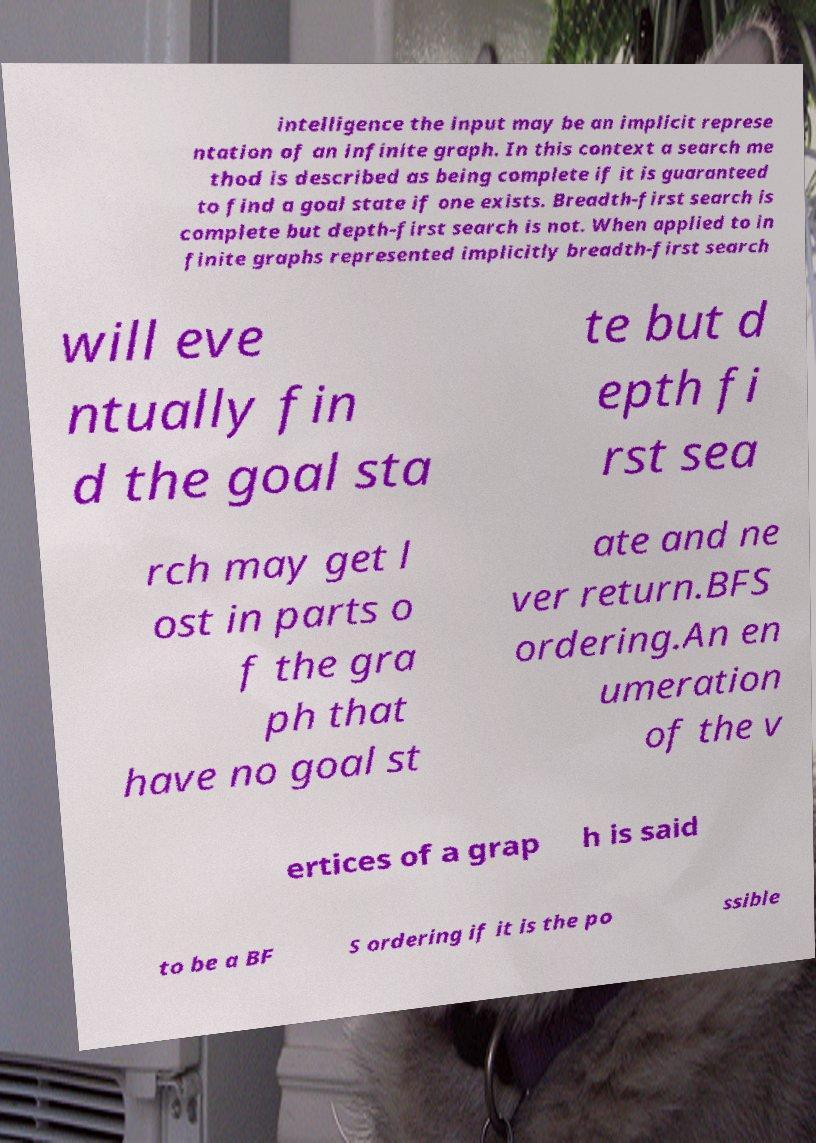What messages or text are displayed in this image? I need them in a readable, typed format. intelligence the input may be an implicit represe ntation of an infinite graph. In this context a search me thod is described as being complete if it is guaranteed to find a goal state if one exists. Breadth-first search is complete but depth-first search is not. When applied to in finite graphs represented implicitly breadth-first search will eve ntually fin d the goal sta te but d epth fi rst sea rch may get l ost in parts o f the gra ph that have no goal st ate and ne ver return.BFS ordering.An en umeration of the v ertices of a grap h is said to be a BF S ordering if it is the po ssible 